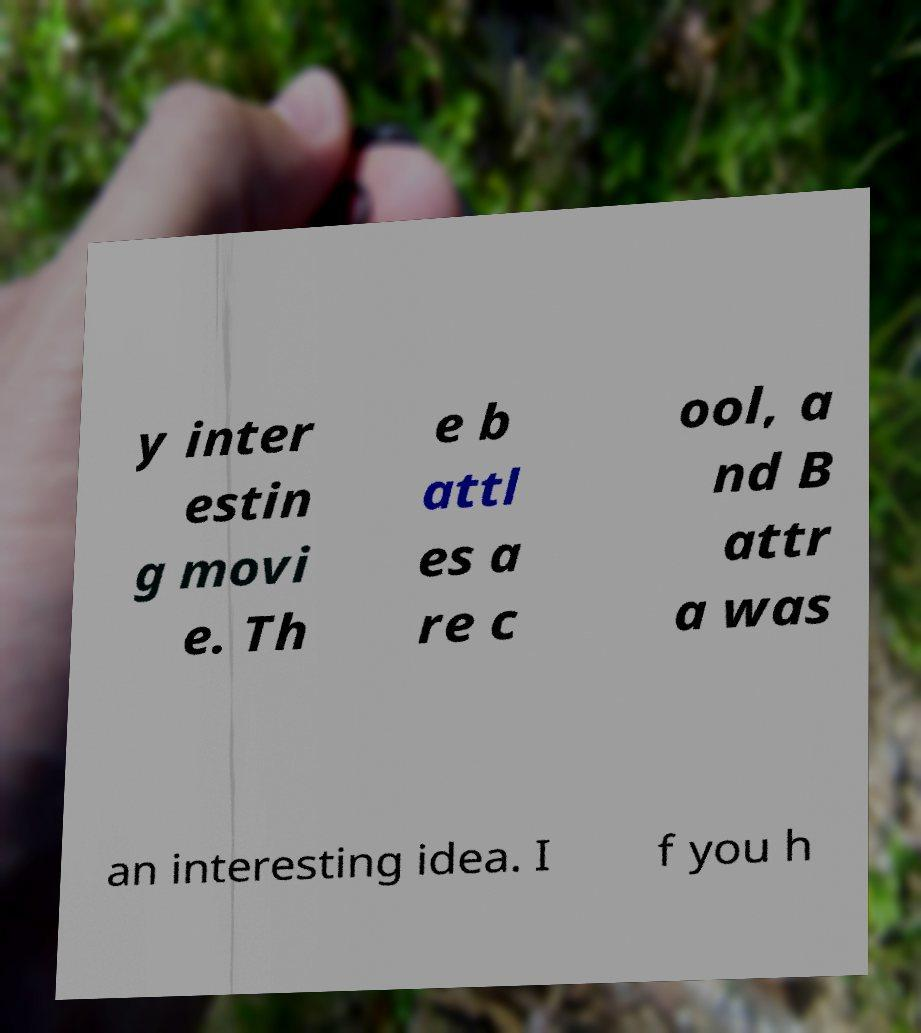Could you extract and type out the text from this image? y inter estin g movi e. Th e b attl es a re c ool, a nd B attr a was an interesting idea. I f you h 